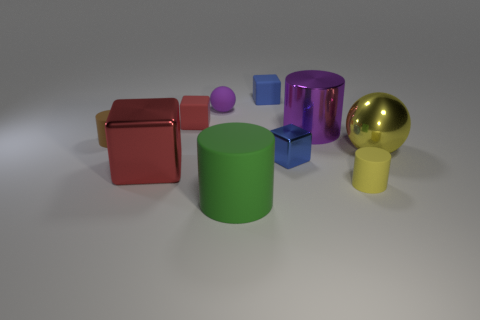Does the yellow matte object have the same shape as the yellow metal thing? no 